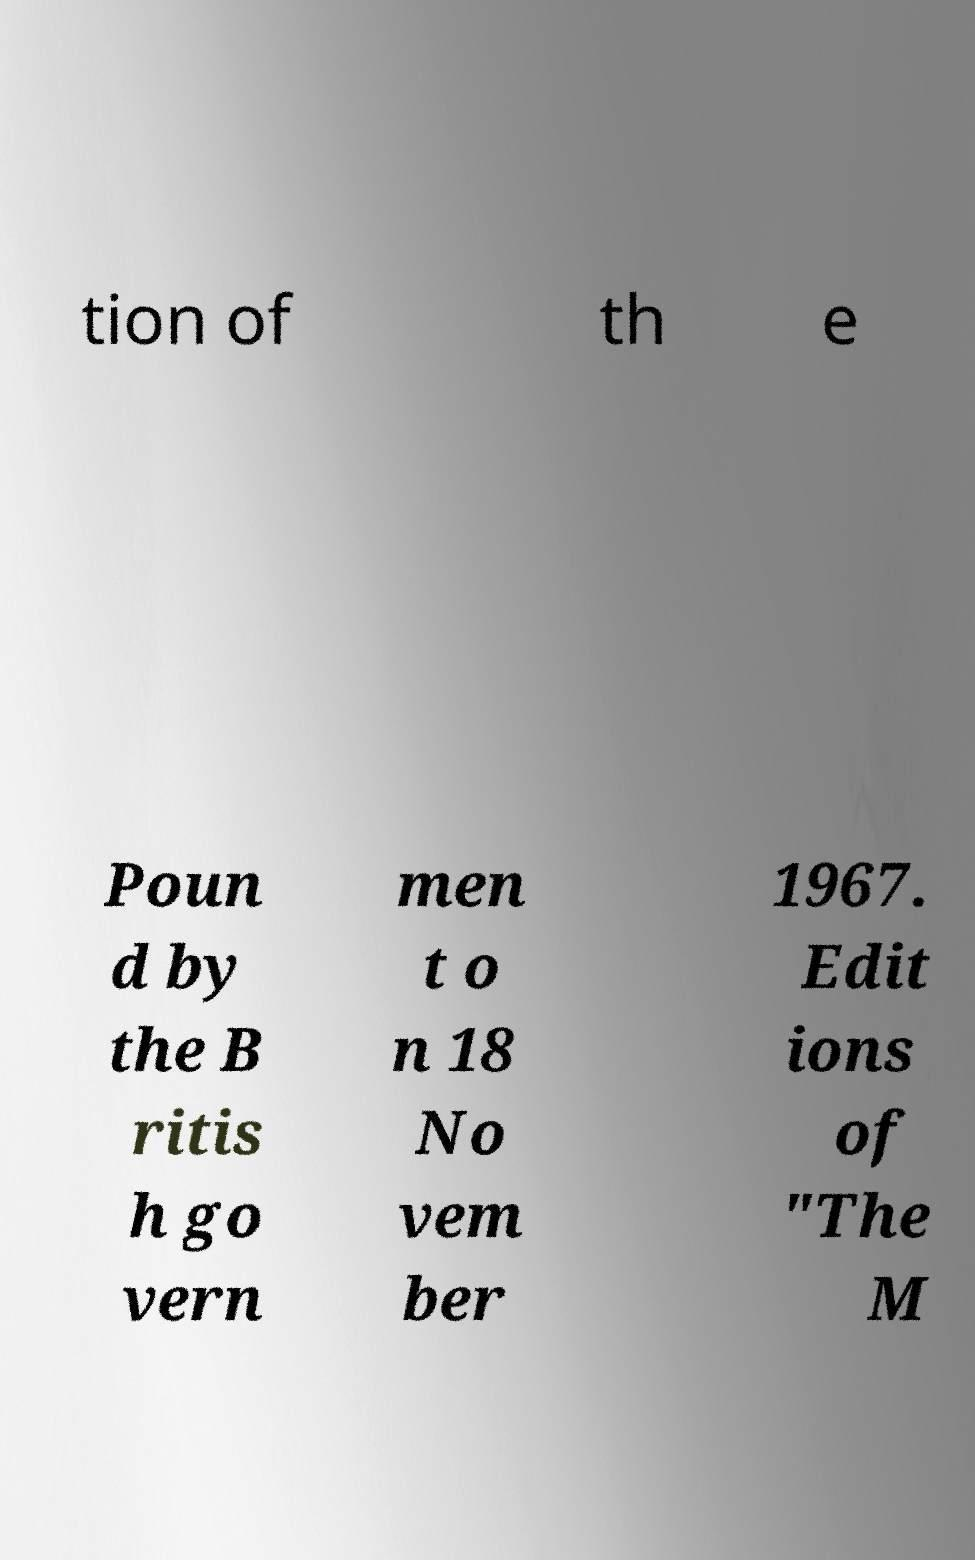Can you accurately transcribe the text from the provided image for me? tion of th e Poun d by the B ritis h go vern men t o n 18 No vem ber 1967. Edit ions of "The M 